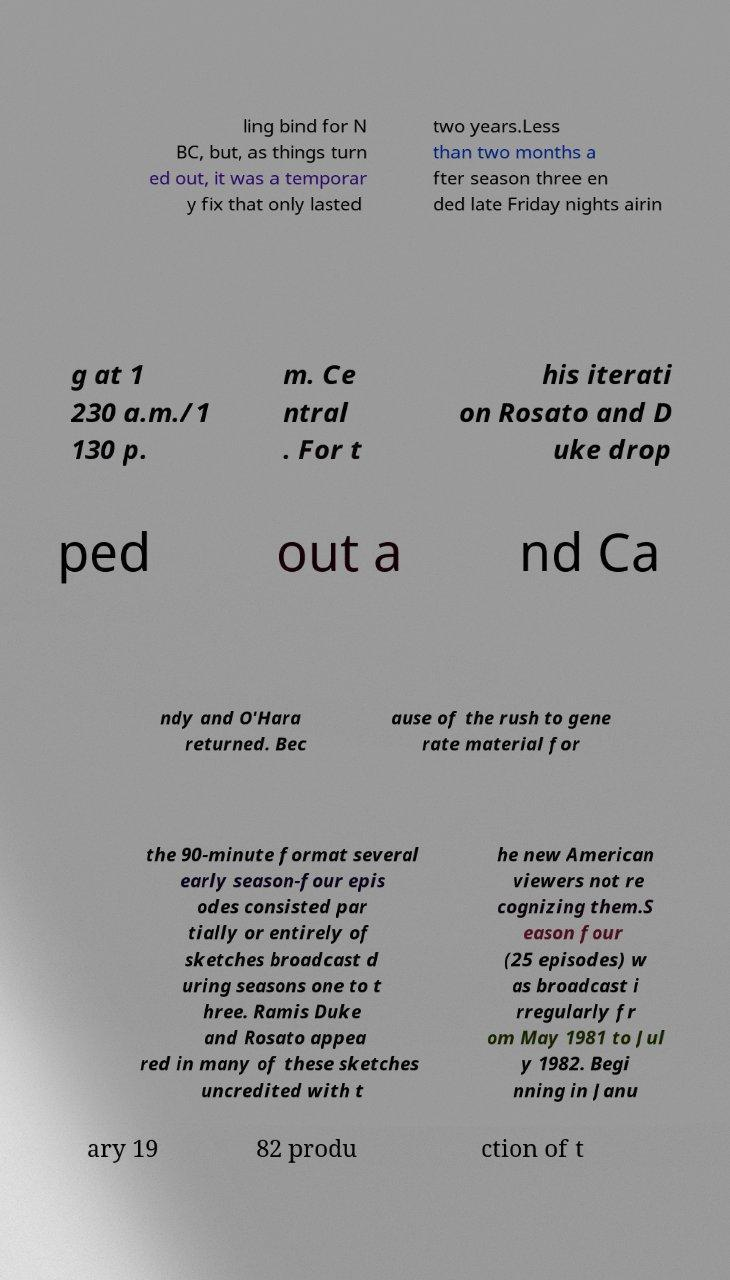Please identify and transcribe the text found in this image. ling bind for N BC, but, as things turn ed out, it was a temporar y fix that only lasted two years.Less than two months a fter season three en ded late Friday nights airin g at 1 230 a.m./1 130 p. m. Ce ntral . For t his iterati on Rosato and D uke drop ped out a nd Ca ndy and O'Hara returned. Bec ause of the rush to gene rate material for the 90-minute format several early season-four epis odes consisted par tially or entirely of sketches broadcast d uring seasons one to t hree. Ramis Duke and Rosato appea red in many of these sketches uncredited with t he new American viewers not re cognizing them.S eason four (25 episodes) w as broadcast i rregularly fr om May 1981 to Jul y 1982. Begi nning in Janu ary 19 82 produ ction of t 